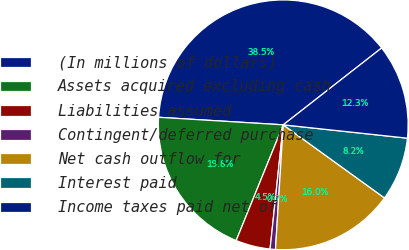Convert chart to OTSL. <chart><loc_0><loc_0><loc_500><loc_500><pie_chart><fcel>(In millions of dollars)<fcel>Assets acquired excluding cash<fcel>Liabilities assumed<fcel>Contingent/deferred purchase<fcel>Net cash outflow for<fcel>Interest paid<fcel>Income taxes paid net of<nl><fcel>38.49%<fcel>19.82%<fcel>4.47%<fcel>0.69%<fcel>16.04%<fcel>8.25%<fcel>12.26%<nl></chart> 